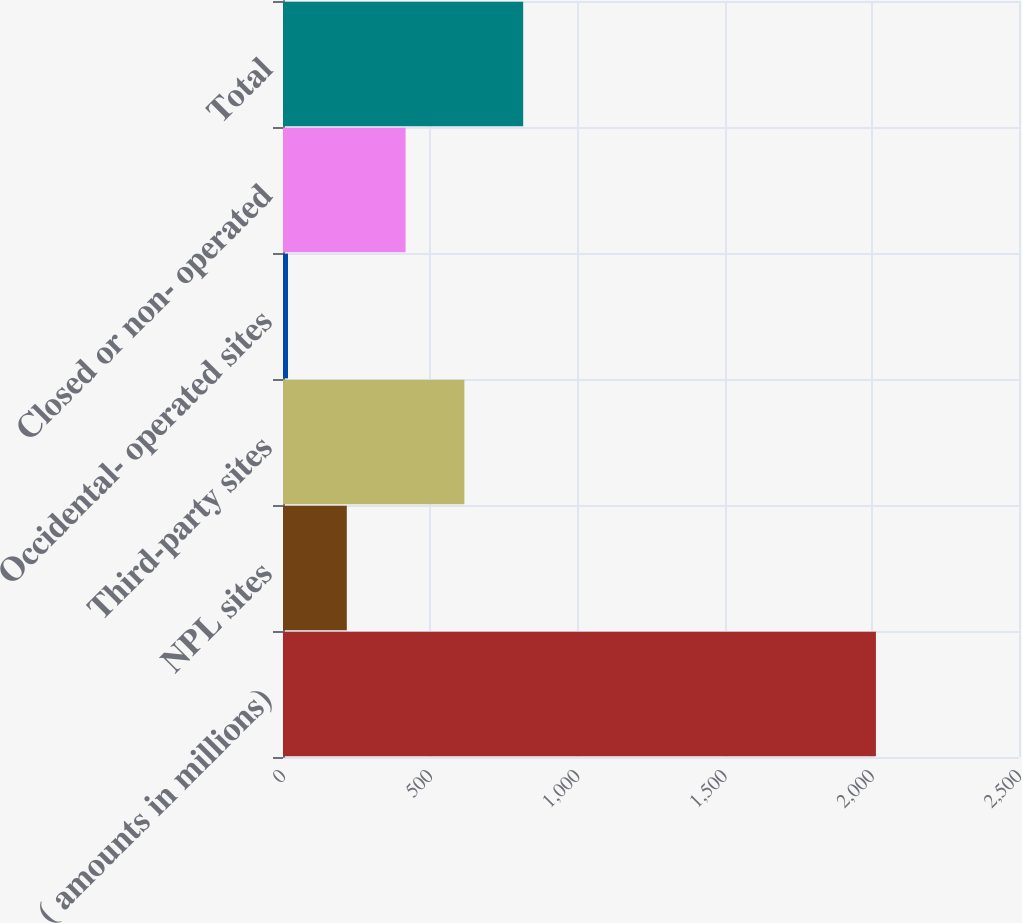Convert chart. <chart><loc_0><loc_0><loc_500><loc_500><bar_chart><fcel>( amounts in millions)<fcel>NPL sites<fcel>Third-party sites<fcel>Occidental- operated sites<fcel>Closed or non- operated<fcel>Total<nl><fcel>2014<fcel>216.7<fcel>616.1<fcel>17<fcel>416.4<fcel>815.8<nl></chart> 